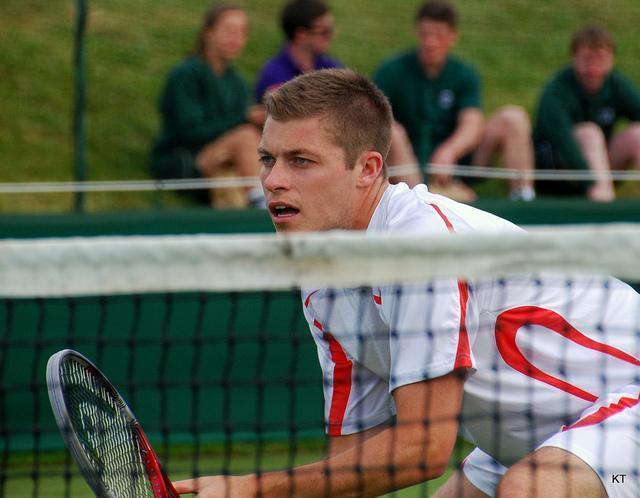How many people are visible?
Give a very brief answer. 5. How many sinks are being used?
Give a very brief answer. 0. 